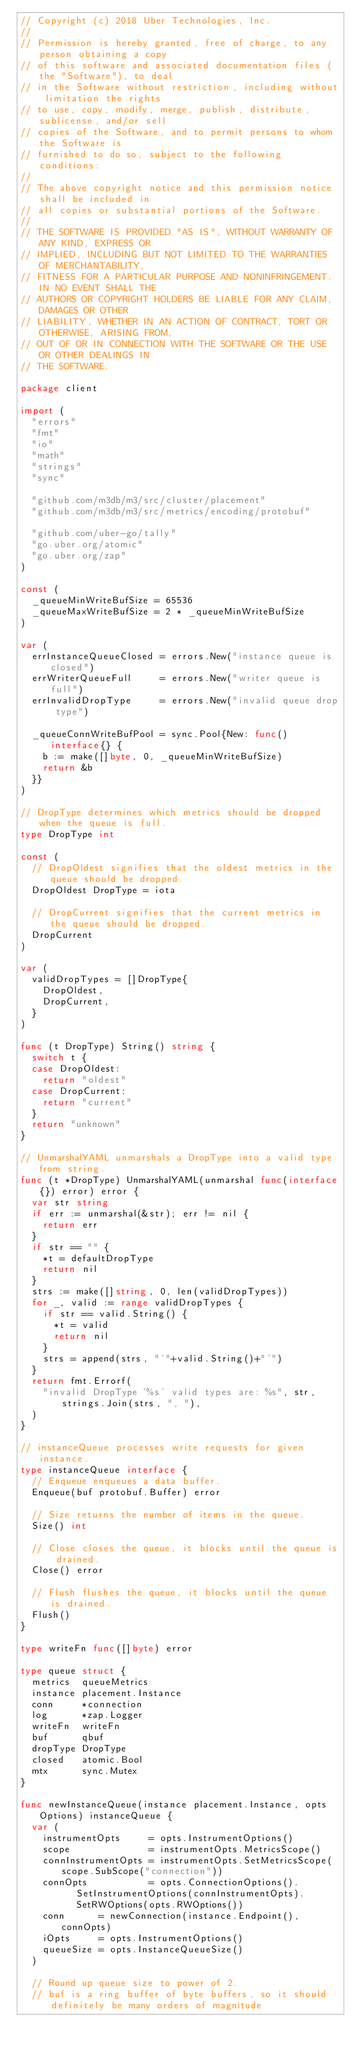Convert code to text. <code><loc_0><loc_0><loc_500><loc_500><_Go_>// Copyright (c) 2018 Uber Technologies, Inc.
//
// Permission is hereby granted, free of charge, to any person obtaining a copy
// of this software and associated documentation files (the "Software"), to deal
// in the Software without restriction, including without limitation the rights
// to use, copy, modify, merge, publish, distribute, sublicense, and/or sell
// copies of the Software, and to permit persons to whom the Software is
// furnished to do so, subject to the following conditions:
//
// The above copyright notice and this permission notice shall be included in
// all copies or substantial portions of the Software.
//
// THE SOFTWARE IS PROVIDED "AS IS", WITHOUT WARRANTY OF ANY KIND, EXPRESS OR
// IMPLIED, INCLUDING BUT NOT LIMITED TO THE WARRANTIES OF MERCHANTABILITY,
// FITNESS FOR A PARTICULAR PURPOSE AND NONINFRINGEMENT. IN NO EVENT SHALL THE
// AUTHORS OR COPYRIGHT HOLDERS BE LIABLE FOR ANY CLAIM, DAMAGES OR OTHER
// LIABILITY, WHETHER IN AN ACTION OF CONTRACT, TORT OR OTHERWISE, ARISING FROM,
// OUT OF OR IN CONNECTION WITH THE SOFTWARE OR THE USE OR OTHER DEALINGS IN
// THE SOFTWARE.

package client

import (
	"errors"
	"fmt"
	"io"
	"math"
	"strings"
	"sync"

	"github.com/m3db/m3/src/cluster/placement"
	"github.com/m3db/m3/src/metrics/encoding/protobuf"

	"github.com/uber-go/tally"
	"go.uber.org/atomic"
	"go.uber.org/zap"
)

const (
	_queueMinWriteBufSize = 65536
	_queueMaxWriteBufSize = 2 * _queueMinWriteBufSize
)

var (
	errInstanceQueueClosed = errors.New("instance queue is closed")
	errWriterQueueFull     = errors.New("writer queue is full")
	errInvalidDropType     = errors.New("invalid queue drop type")

	_queueConnWriteBufPool = sync.Pool{New: func() interface{} {
		b := make([]byte, 0, _queueMinWriteBufSize)
		return &b
	}}
)

// DropType determines which metrics should be dropped when the queue is full.
type DropType int

const (
	// DropOldest signifies that the oldest metrics in the queue should be dropped.
	DropOldest DropType = iota

	// DropCurrent signifies that the current metrics in the queue should be dropped.
	DropCurrent
)

var (
	validDropTypes = []DropType{
		DropOldest,
		DropCurrent,
	}
)

func (t DropType) String() string {
	switch t {
	case DropOldest:
		return "oldest"
	case DropCurrent:
		return "current"
	}
	return "unknown"
}

// UnmarshalYAML unmarshals a DropType into a valid type from string.
func (t *DropType) UnmarshalYAML(unmarshal func(interface{}) error) error {
	var str string
	if err := unmarshal(&str); err != nil {
		return err
	}
	if str == "" {
		*t = defaultDropType
		return nil
	}
	strs := make([]string, 0, len(validDropTypes))
	for _, valid := range validDropTypes {
		if str == valid.String() {
			*t = valid
			return nil
		}
		strs = append(strs, "'"+valid.String()+"'")
	}
	return fmt.Errorf(
		"invalid DropType '%s' valid types are: %s", str, strings.Join(strs, ", "),
	)
}

// instanceQueue processes write requests for given instance.
type instanceQueue interface {
	// Enqueue enqueues a data buffer.
	Enqueue(buf protobuf.Buffer) error

	// Size returns the number of items in the queue.
	Size() int

	// Close closes the queue, it blocks until the queue is drained.
	Close() error

	// Flush flushes the queue, it blocks until the queue is drained.
	Flush()
}

type writeFn func([]byte) error

type queue struct {
	metrics  queueMetrics
	instance placement.Instance
	conn     *connection
	log      *zap.Logger
	writeFn  writeFn
	buf      qbuf
	dropType DropType
	closed   atomic.Bool
	mtx      sync.Mutex
}

func newInstanceQueue(instance placement.Instance, opts Options) instanceQueue {
	var (
		instrumentOpts     = opts.InstrumentOptions()
		scope              = instrumentOpts.MetricsScope()
		connInstrumentOpts = instrumentOpts.SetMetricsScope(scope.SubScope("connection"))
		connOpts           = opts.ConnectionOptions().
					SetInstrumentOptions(connInstrumentOpts).
					SetRWOptions(opts.RWOptions())
		conn      = newConnection(instance.Endpoint(), connOpts)
		iOpts     = opts.InstrumentOptions()
		queueSize = opts.InstanceQueueSize()
	)

	// Round up queue size to power of 2.
	// buf is a ring buffer of byte buffers, so it should definitely be many orders of magnitude</code> 